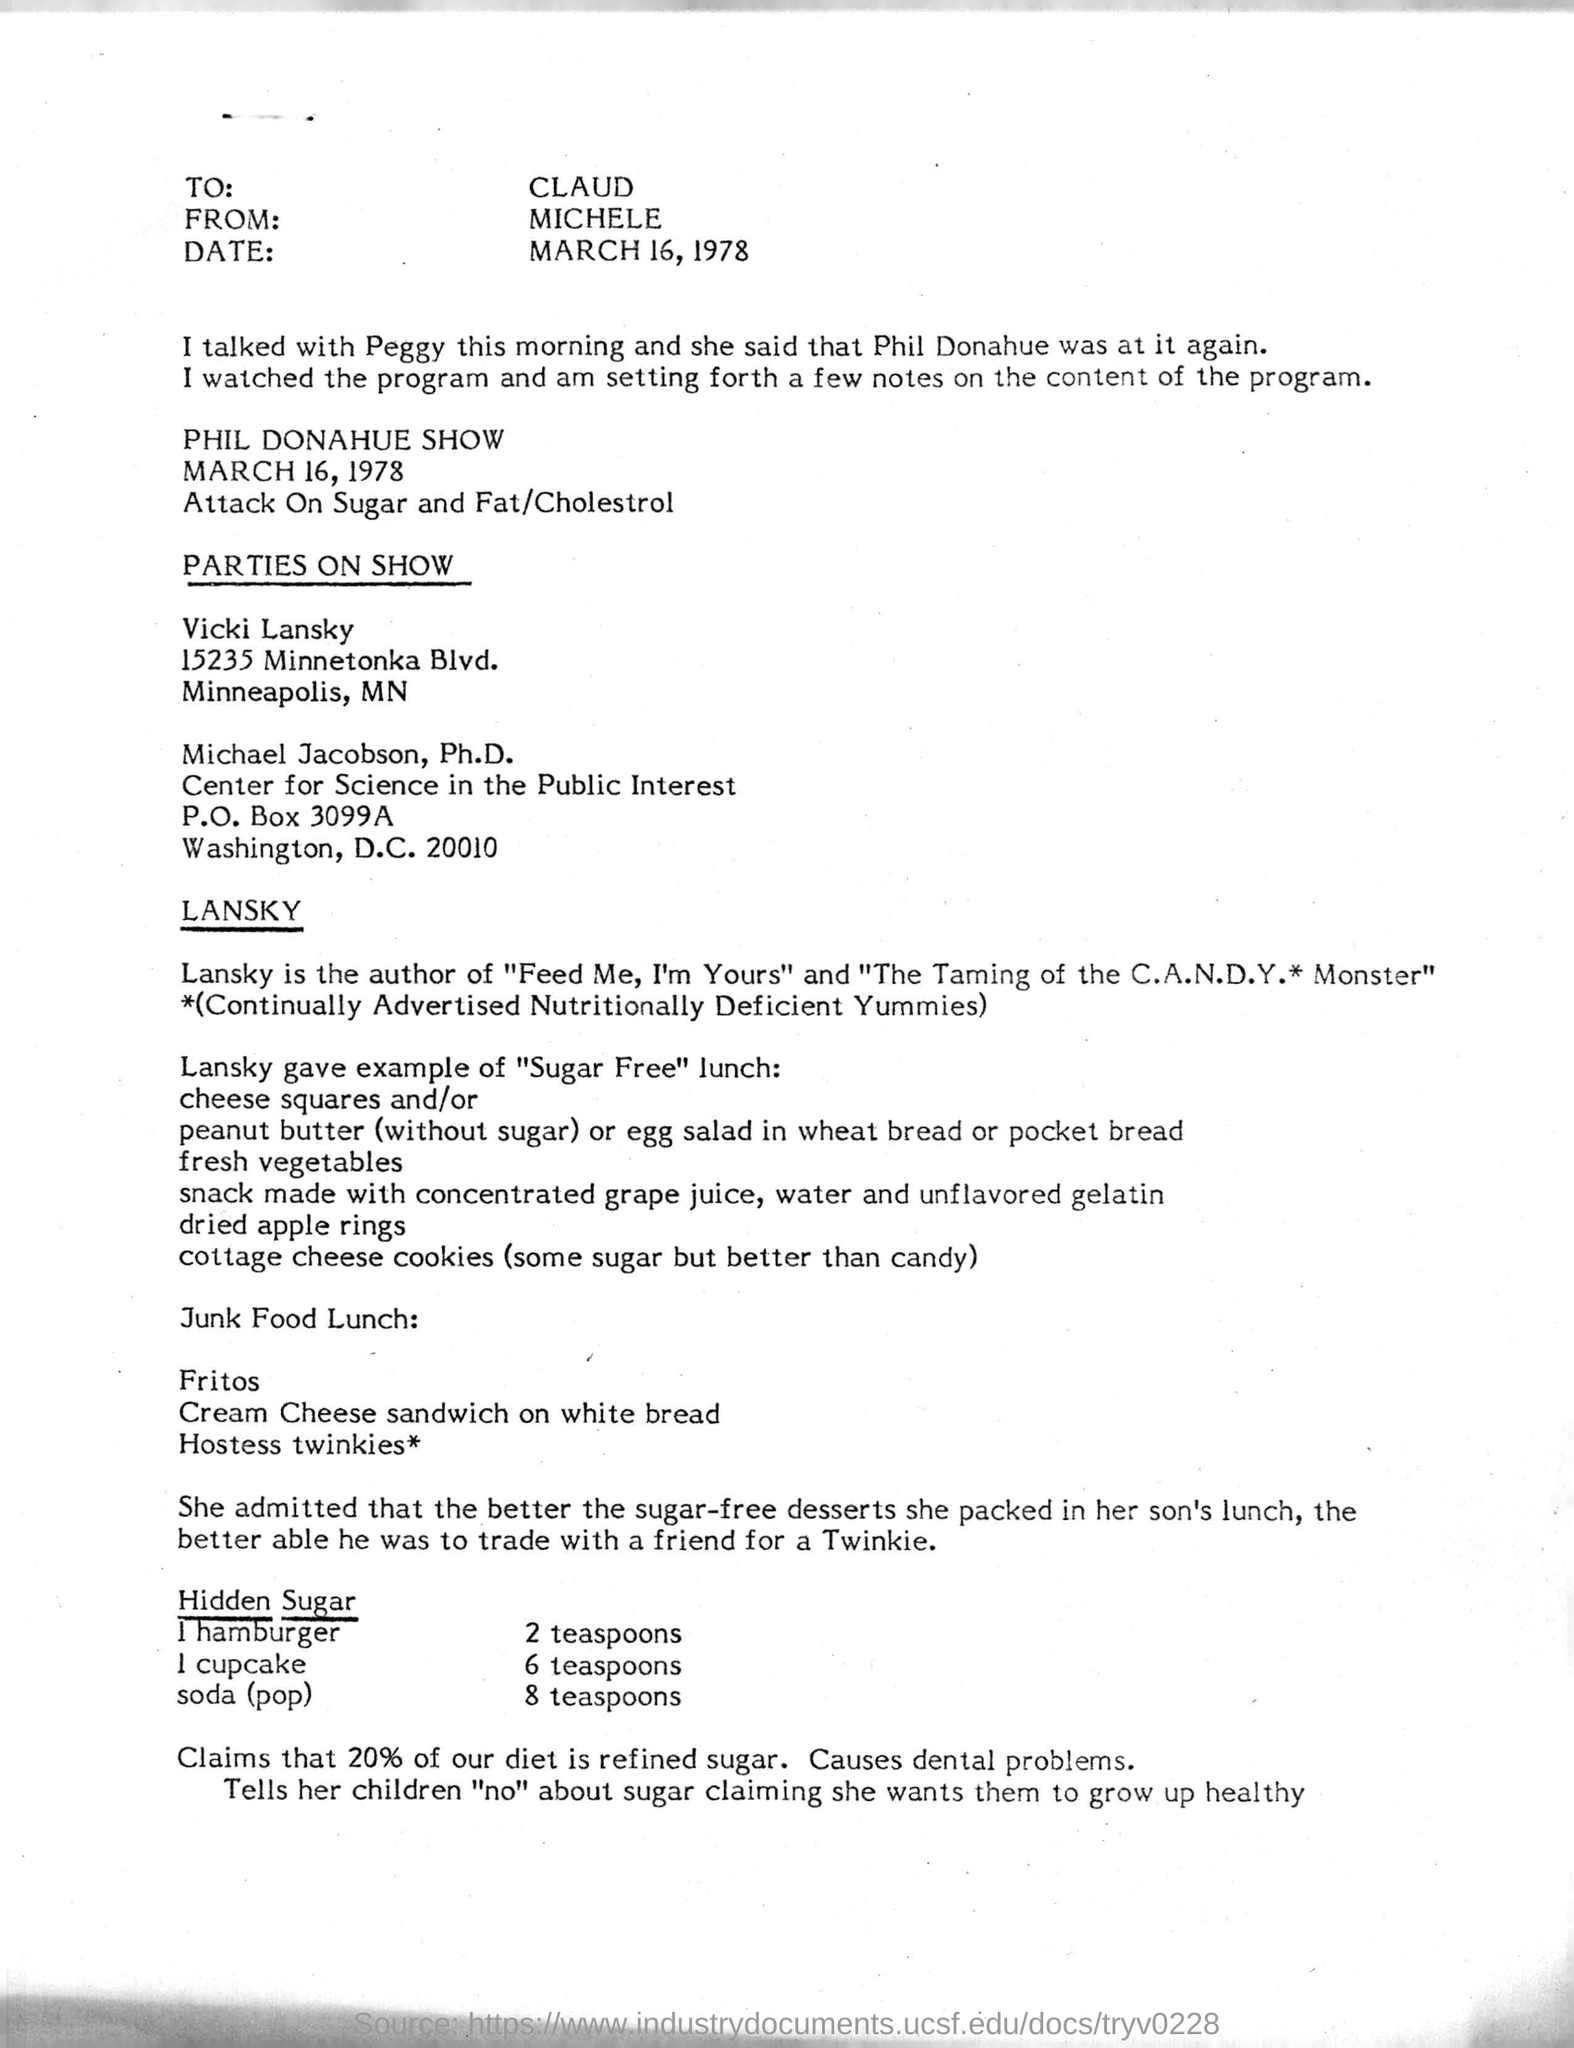Give some essential details in this illustration. This letter is addressed to CLAUD. The author of "The Taming of the C.A.N.D.Y. Monster" is LANSKY. The letter is from Michele. 